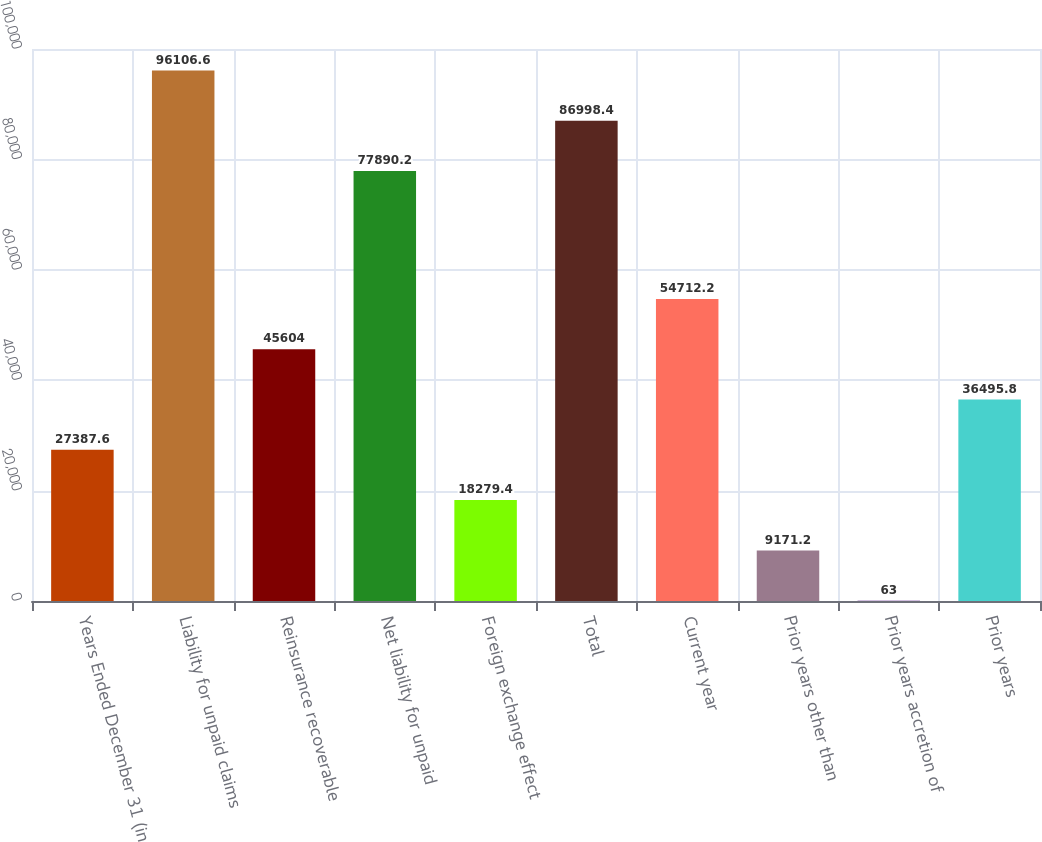Convert chart. <chart><loc_0><loc_0><loc_500><loc_500><bar_chart><fcel>Years Ended December 31 (in<fcel>Liability for unpaid claims<fcel>Reinsurance recoverable<fcel>Net liability for unpaid<fcel>Foreign exchange effect<fcel>Total<fcel>Current year<fcel>Prior years other than<fcel>Prior years accretion of<fcel>Prior years<nl><fcel>27387.6<fcel>96106.6<fcel>45604<fcel>77890.2<fcel>18279.4<fcel>86998.4<fcel>54712.2<fcel>9171.2<fcel>63<fcel>36495.8<nl></chart> 